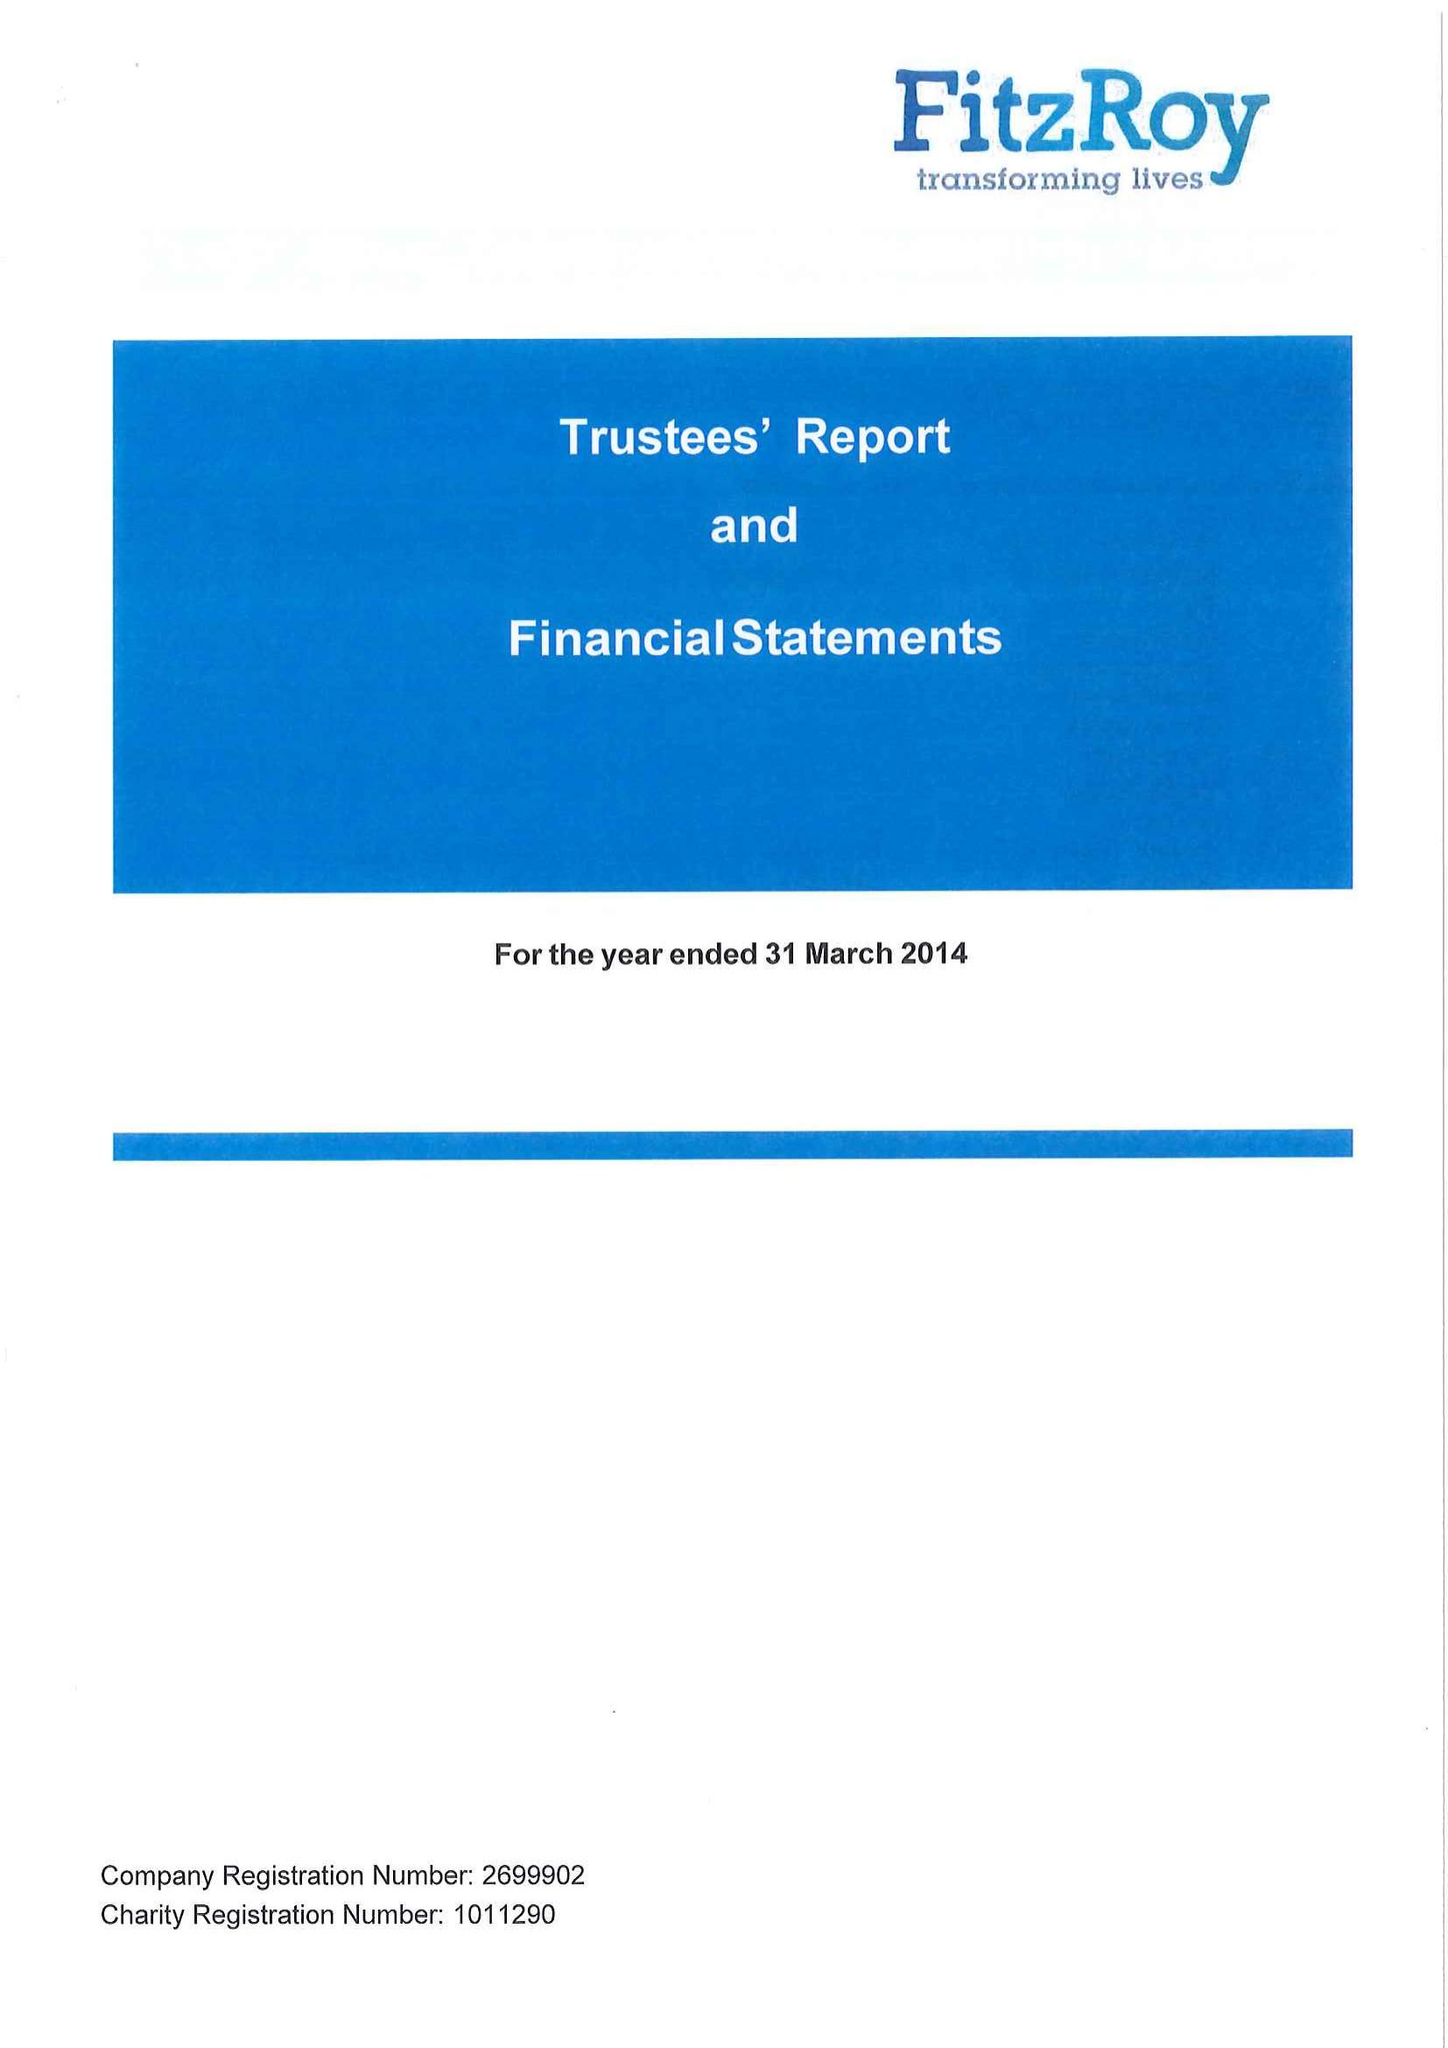What is the value for the report_date?
Answer the question using a single word or phrase. 2014-03-31 